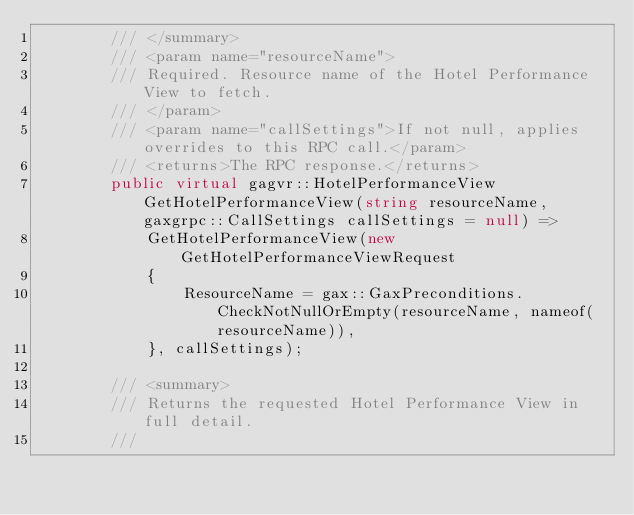Convert code to text. <code><loc_0><loc_0><loc_500><loc_500><_C#_>        /// </summary>
        /// <param name="resourceName">
        /// Required. Resource name of the Hotel Performance View to fetch.
        /// </param>
        /// <param name="callSettings">If not null, applies overrides to this RPC call.</param>
        /// <returns>The RPC response.</returns>
        public virtual gagvr::HotelPerformanceView GetHotelPerformanceView(string resourceName, gaxgrpc::CallSettings callSettings = null) =>
            GetHotelPerformanceView(new GetHotelPerformanceViewRequest
            {
                ResourceName = gax::GaxPreconditions.CheckNotNullOrEmpty(resourceName, nameof(resourceName)),
            }, callSettings);

        /// <summary>
        /// Returns the requested Hotel Performance View in full detail.
        /// </code> 